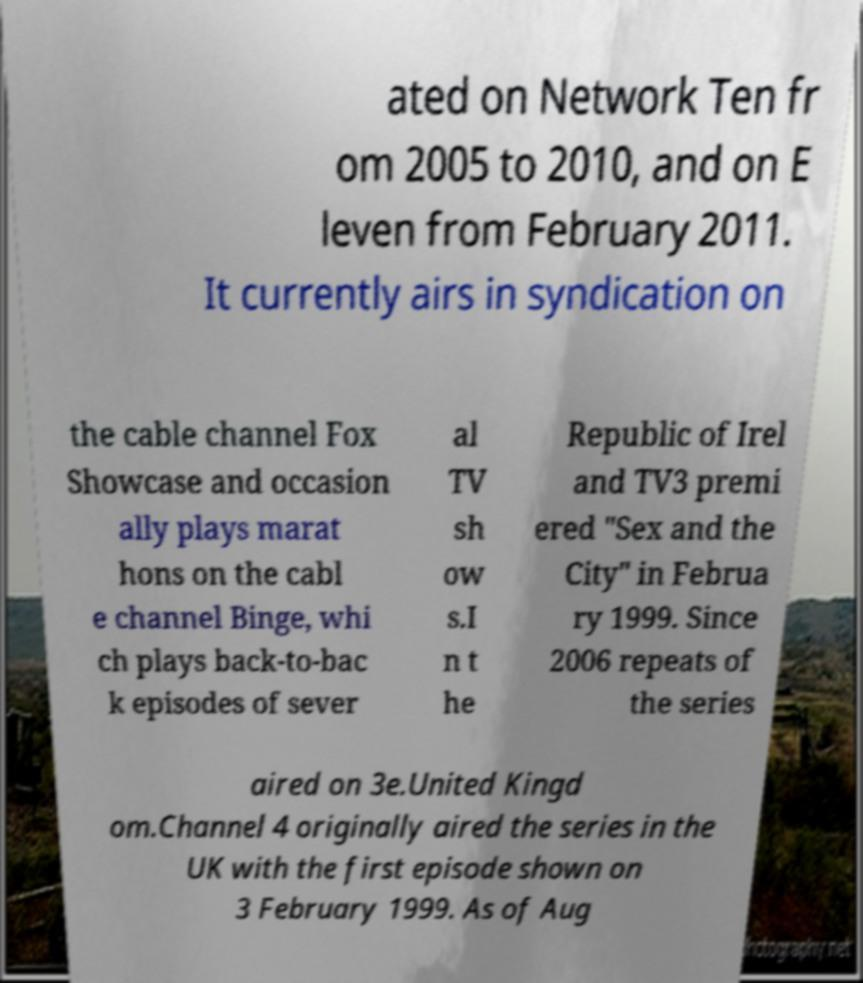For documentation purposes, I need the text within this image transcribed. Could you provide that? ated on Network Ten fr om 2005 to 2010, and on E leven from February 2011. It currently airs in syndication on the cable channel Fox Showcase and occasion ally plays marat hons on the cabl e channel Binge, whi ch plays back-to-bac k episodes of sever al TV sh ow s.I n t he Republic of Irel and TV3 premi ered "Sex and the City" in Februa ry 1999. Since 2006 repeats of the series aired on 3e.United Kingd om.Channel 4 originally aired the series in the UK with the first episode shown on 3 February 1999. As of Aug 